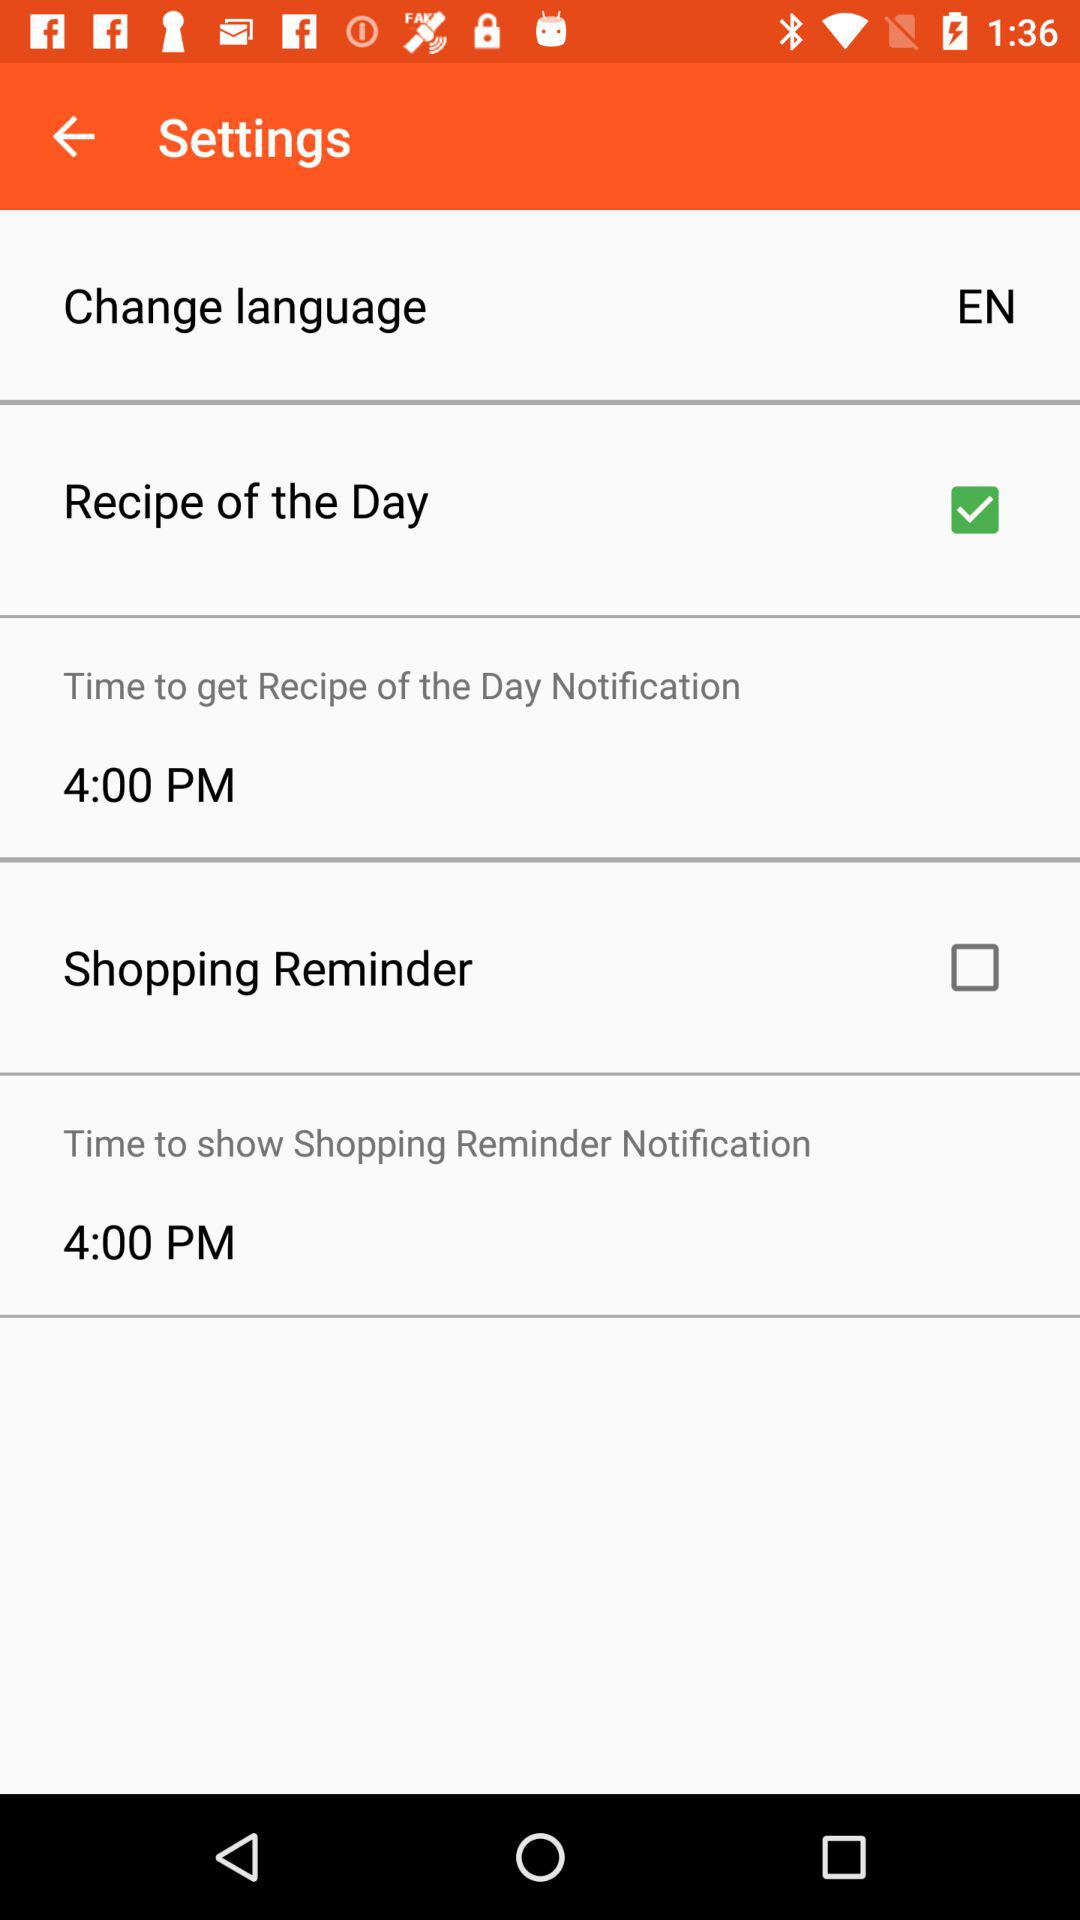What is the time mentioned for "Time to show Shopping Reminder Notification"? The time mentioned for "Time to show Shopping Reminder Notification" is 4:00 PM. 